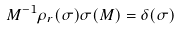<formula> <loc_0><loc_0><loc_500><loc_500>M ^ { - 1 } \rho _ { r } ( \sigma ) \sigma ( M ) = \delta ( \sigma )</formula> 